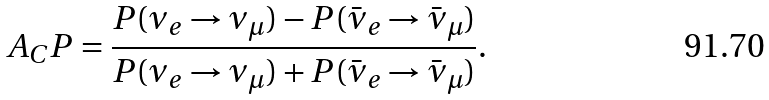<formula> <loc_0><loc_0><loc_500><loc_500>A _ { C } P = \frac { P ( \nu _ { e } \rightarrow \nu _ { \mu } ) - P ( \bar { \nu } _ { e } \rightarrow \bar { \nu } _ { \mu } ) } { P ( \nu _ { e } \rightarrow \nu _ { \mu } ) + P ( \bar { \nu } _ { e } \rightarrow \bar { \nu } _ { \mu } ) } .</formula> 